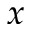<formula> <loc_0><loc_0><loc_500><loc_500>x</formula> 